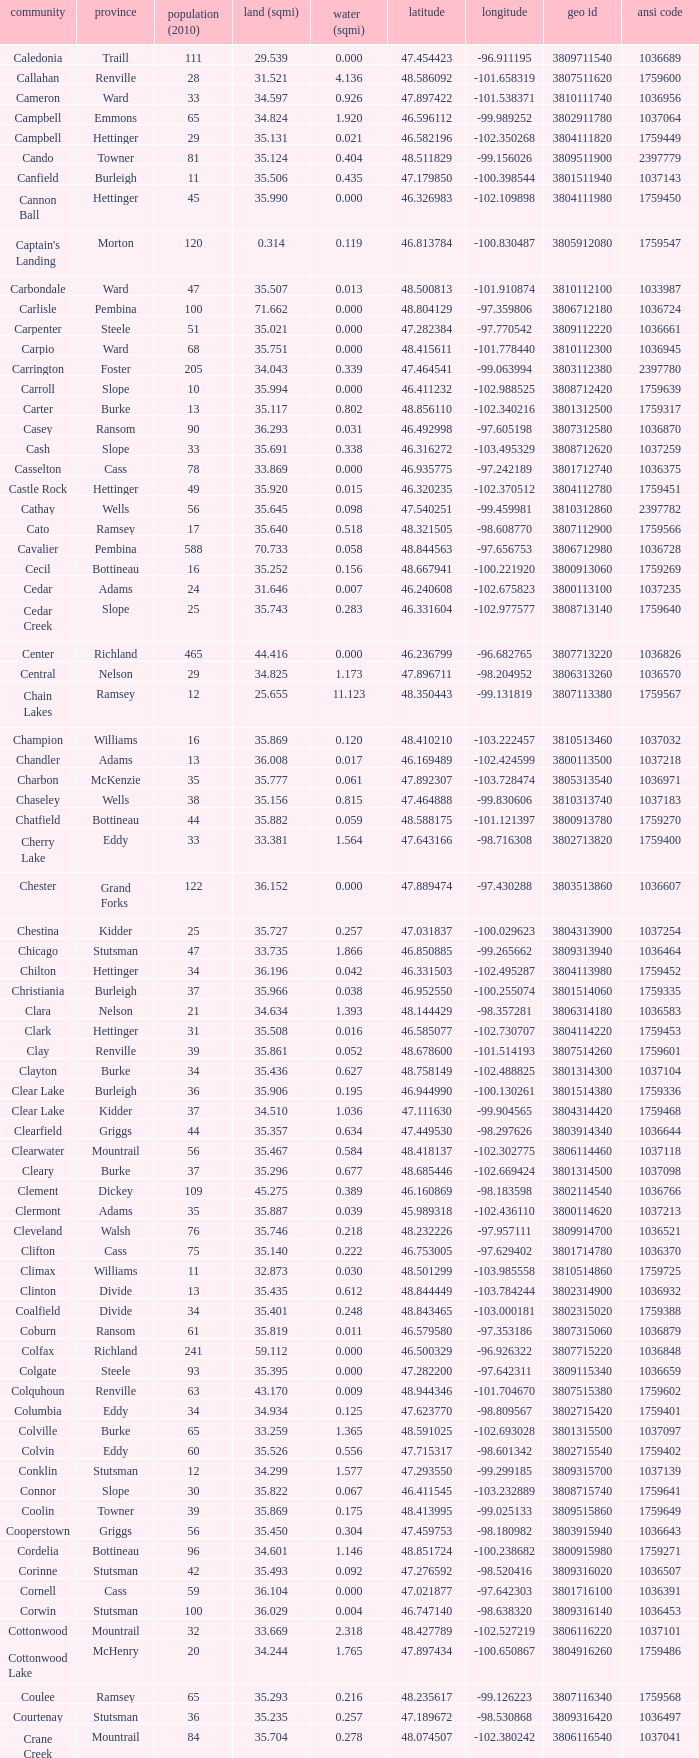What was the county located at a latitude of 4 Kidder. 